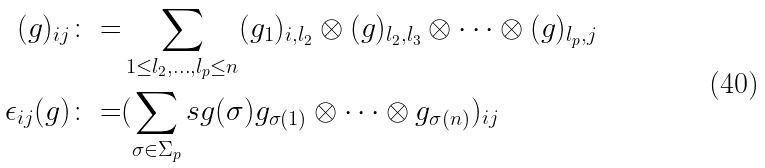<formula> <loc_0><loc_0><loc_500><loc_500>( g ) _ { i j } \colon = & \sum _ { 1 \leq l _ { 2 } , \dots , l _ { p } \leq n } ( g _ { 1 } ) _ { i , l _ { 2 } } \otimes ( g ) _ { l _ { 2 } , l _ { 3 } } \otimes \dots \otimes ( g ) _ { l _ { p } , j } \\ \epsilon _ { i j } ( g ) \colon = & ( \sum _ { \sigma \in \Sigma _ { p } } s g ( \sigma ) g _ { \sigma ( 1 ) } \otimes \dots \otimes g _ { \sigma ( n ) } ) _ { i j }</formula> 